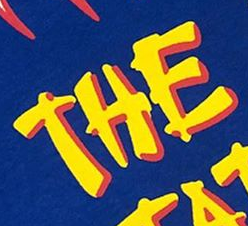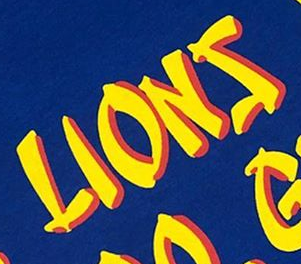Transcribe the words shown in these images in order, separated by a semicolon. THE; LIONS 